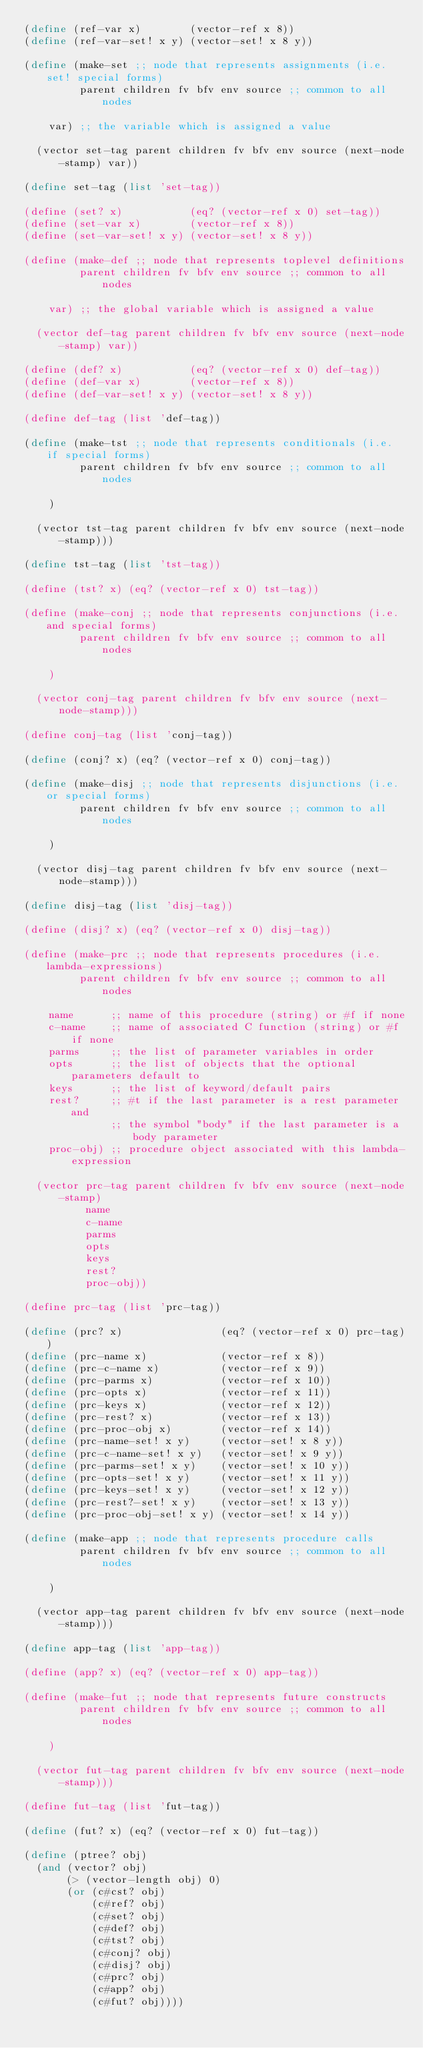Convert code to text. <code><loc_0><loc_0><loc_500><loc_500><_Scheme_>(define (ref-var x)        (vector-ref x 8))
(define (ref-var-set! x y) (vector-set! x 8 y))

(define (make-set ;; node that represents assignments (i.e. set! special forms)
         parent children fv bfv env source ;; common to all nodes

    var) ;; the variable which is assigned a value

  (vector set-tag parent children fv bfv env source (next-node-stamp) var))

(define set-tag (list 'set-tag))

(define (set? x)           (eq? (vector-ref x 0) set-tag))
(define (set-var x)        (vector-ref x 8))
(define (set-var-set! x y) (vector-set! x 8 y))

(define (make-def ;; node that represents toplevel definitions
         parent children fv bfv env source ;; common to all nodes

    var) ;; the global variable which is assigned a value

  (vector def-tag parent children fv bfv env source (next-node-stamp) var))

(define (def? x)           (eq? (vector-ref x 0) def-tag))
(define (def-var x)        (vector-ref x 8))
(define (def-var-set! x y) (vector-set! x 8 y))

(define def-tag (list 'def-tag))

(define (make-tst ;; node that represents conditionals (i.e. if special forms)
         parent children fv bfv env source ;; common to all nodes

    )

  (vector tst-tag parent children fv bfv env source (next-node-stamp)))

(define tst-tag (list 'tst-tag))

(define (tst? x) (eq? (vector-ref x 0) tst-tag))

(define (make-conj ;; node that represents conjunctions (i.e. and special forms)
         parent children fv bfv env source ;; common to all nodes

    )

  (vector conj-tag parent children fv bfv env source (next-node-stamp)))

(define conj-tag (list 'conj-tag))

(define (conj? x) (eq? (vector-ref x 0) conj-tag))

(define (make-disj ;; node that represents disjunctions (i.e. or special forms)
         parent children fv bfv env source ;; common to all nodes

    )

  (vector disj-tag parent children fv bfv env source (next-node-stamp)))

(define disj-tag (list 'disj-tag))

(define (disj? x) (eq? (vector-ref x 0) disj-tag))

(define (make-prc ;; node that represents procedures (i.e. lambda-expressions)
         parent children fv bfv env source ;; common to all nodes

    name      ;; name of this procedure (string) or #f if none
    c-name    ;; name of associated C function (string) or #f if none
    parms     ;; the list of parameter variables in order
    opts      ;; the list of objects that the optional parameters default to
    keys      ;; the list of keyword/default pairs
    rest?     ;; #t if the last parameter is a rest parameter and
              ;; the symbol "body" if the last parameter is a body parameter
    proc-obj) ;; procedure object associated with this lambda-expression

  (vector prc-tag parent children fv bfv env source (next-node-stamp)
          name
          c-name
          parms
          opts
          keys
          rest?
          proc-obj))

(define prc-tag (list 'prc-tag))

(define (prc? x)                (eq? (vector-ref x 0) prc-tag))
(define (prc-name x)            (vector-ref x 8))
(define (prc-c-name x)          (vector-ref x 9))
(define (prc-parms x)           (vector-ref x 10))
(define (prc-opts x)            (vector-ref x 11))
(define (prc-keys x)            (vector-ref x 12))
(define (prc-rest? x)           (vector-ref x 13))
(define (prc-proc-obj x)        (vector-ref x 14))
(define (prc-name-set! x y)     (vector-set! x 8 y))
(define (prc-c-name-set! x y)   (vector-set! x 9 y))
(define (prc-parms-set! x y)    (vector-set! x 10 y))
(define (prc-opts-set! x y)     (vector-set! x 11 y))
(define (prc-keys-set! x y)     (vector-set! x 12 y))
(define (prc-rest?-set! x y)    (vector-set! x 13 y))
(define (prc-proc-obj-set! x y) (vector-set! x 14 y))

(define (make-app ;; node that represents procedure calls
         parent children fv bfv env source ;; common to all nodes

    )

  (vector app-tag parent children fv bfv env source (next-node-stamp)))

(define app-tag (list 'app-tag))

(define (app? x) (eq? (vector-ref x 0) app-tag))

(define (make-fut ;; node that represents future constructs
         parent children fv bfv env source ;; common to all nodes

    )

  (vector fut-tag parent children fv bfv env source (next-node-stamp)))

(define fut-tag (list 'fut-tag))

(define (fut? x) (eq? (vector-ref x 0) fut-tag))

(define (ptree? obj)
  (and (vector? obj)
       (> (vector-length obj) 0)
       (or (c#cst? obj)
           (c#ref? obj)
           (c#set? obj)
           (c#def? obj)
           (c#tst? obj)
           (c#conj? obj)
           (c#disj? obj)
           (c#prc? obj)
           (c#app? obj)
           (c#fut? obj))))
</code> 